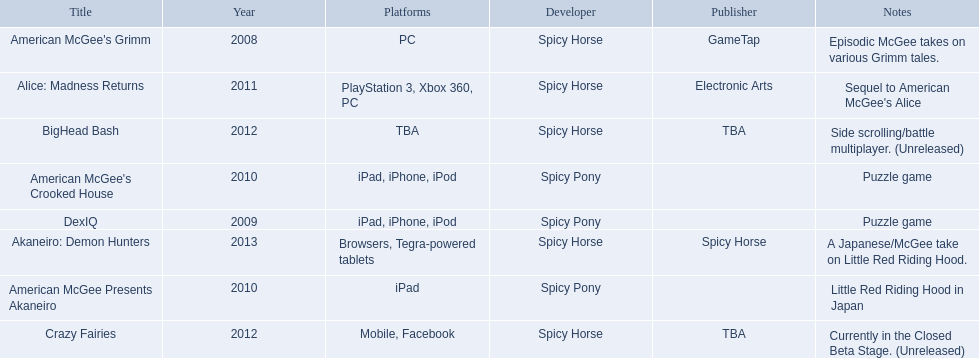Which spicy horse titles are shown? American McGee's Grimm, DexIQ, American McGee Presents Akaneiro, American McGee's Crooked House, Alice: Madness Returns, BigHead Bash, Crazy Fairies, Akaneiro: Demon Hunters. Of those, which are for the ipad? DexIQ, American McGee Presents Akaneiro, American McGee's Crooked House. Which of those are not for the iphone or ipod? American McGee Presents Akaneiro. 